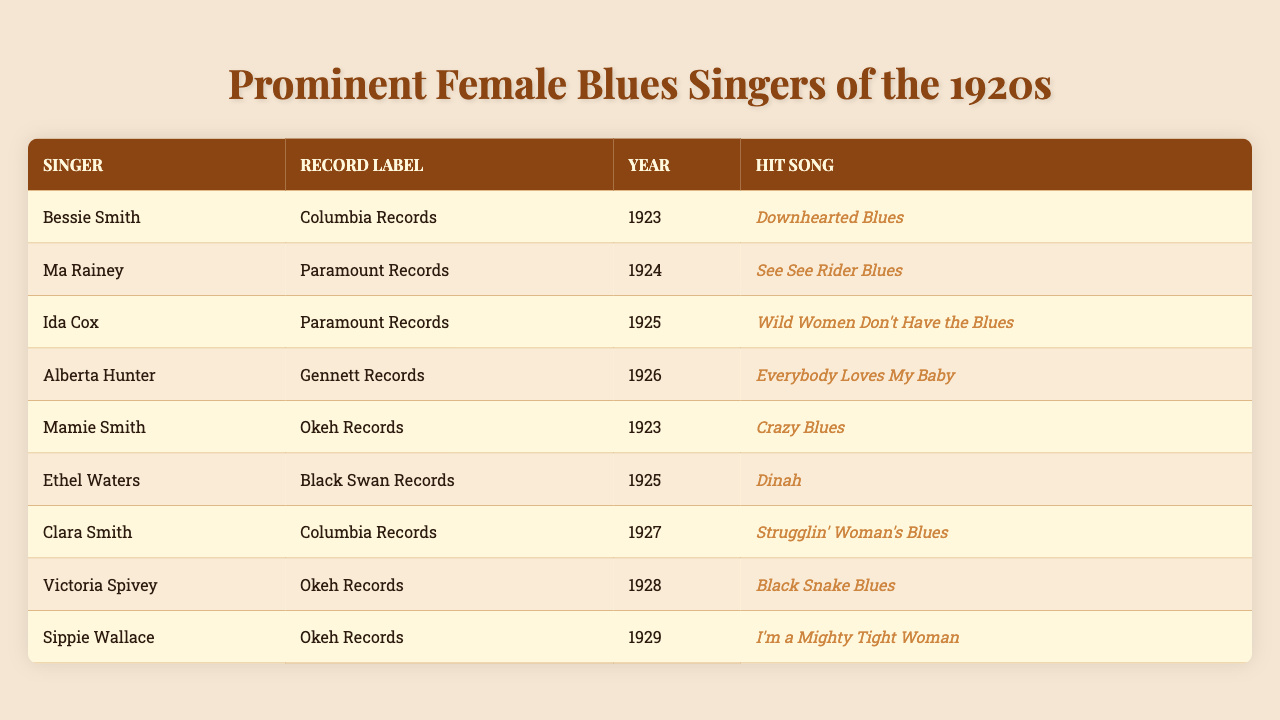What was the hit song released by Bessie Smith? The table lists the records for various singers; Bessie Smith's entry shows her hit song as "Downhearted Blues."
Answer: Downhearted Blues Which record label did Ma Rainey sign with? Looking at the row corresponding to Ma Rainey in the table, it indicates that she was signed with Paramount Records.
Answer: Paramount Records How many different record labels are represented in the table? By examining the labels listed, there are eight unique record labels: Columbia, Paramount, Okeh, Gennett, Black Swan, Victor, Brunswick, and Vocalion. Thus, the total is eight.
Answer: 8 What year did Clara Smith release "Strugglin' Woman's Blues"? Referring to Clara Smith's entry in the table, it shows that she released this hit song in the year 1927.
Answer: 1927 Is Ethel Waters associated with Okeh Records? The table entry for Ethel Waters shows she is associated with Black Swan Records, not Okeh Records, indicating this statement is false.
Answer: No Which singer released the most recent hit song in the table? By comparing the years listed for each singer, Sippie Wallace's song “I'm a Mighty Tight Woman” in 1929 is the most recent in the table.
Answer: Sippie Wallace How many singers have recordings under Paramount Records? The table has two entries for Paramount Records: Ma Rainey and Ida Cox, thus there are two singers associated with this label.
Answer: 2 Which singer had a hit song in the same year as Mamie Smith? A review of the table indicates that Bessie Smith also had a hit song in 1923, the same year as Mamie Smith's "Crazy Blues."
Answer: Bessie Smith What is the average year of release for the hits listed in the table? The years of releases are 1923, 1924, 1925, 1926, 1927, 1928, and 1929. Summing these gives 13, and since there are 7 data points, the average year is 13/7 which approximates to 1926.
Answer: 1926 Does Alberta Hunter have a song listed in the same record label as Victoria Spivey? The table shows that Alberta Hunter is with Gennett Records while Victoria Spivey is with Okeh Records, indicating that they do not share the same record label.
Answer: No 